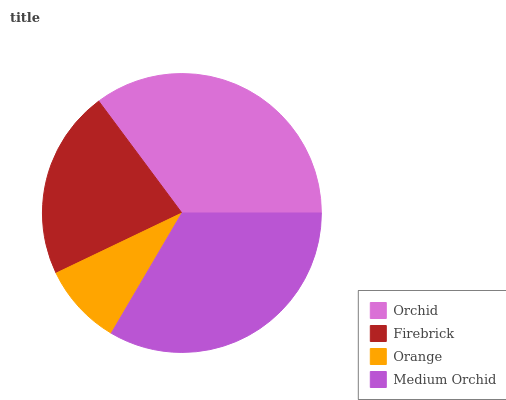Is Orange the minimum?
Answer yes or no. Yes. Is Orchid the maximum?
Answer yes or no. Yes. Is Firebrick the minimum?
Answer yes or no. No. Is Firebrick the maximum?
Answer yes or no. No. Is Orchid greater than Firebrick?
Answer yes or no. Yes. Is Firebrick less than Orchid?
Answer yes or no. Yes. Is Firebrick greater than Orchid?
Answer yes or no. No. Is Orchid less than Firebrick?
Answer yes or no. No. Is Medium Orchid the high median?
Answer yes or no. Yes. Is Firebrick the low median?
Answer yes or no. Yes. Is Orange the high median?
Answer yes or no. No. Is Orchid the low median?
Answer yes or no. No. 